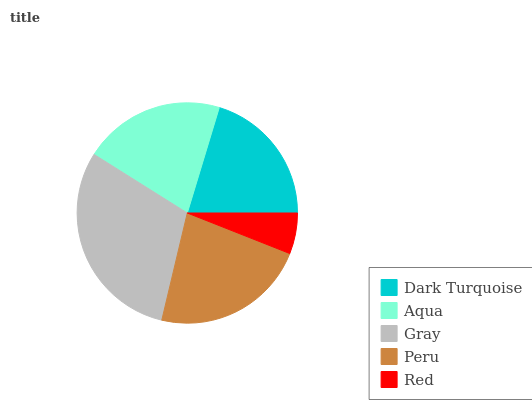Is Red the minimum?
Answer yes or no. Yes. Is Gray the maximum?
Answer yes or no. Yes. Is Aqua the minimum?
Answer yes or no. No. Is Aqua the maximum?
Answer yes or no. No. Is Aqua greater than Dark Turquoise?
Answer yes or no. Yes. Is Dark Turquoise less than Aqua?
Answer yes or no. Yes. Is Dark Turquoise greater than Aqua?
Answer yes or no. No. Is Aqua less than Dark Turquoise?
Answer yes or no. No. Is Aqua the high median?
Answer yes or no. Yes. Is Aqua the low median?
Answer yes or no. Yes. Is Red the high median?
Answer yes or no. No. Is Peru the low median?
Answer yes or no. No. 